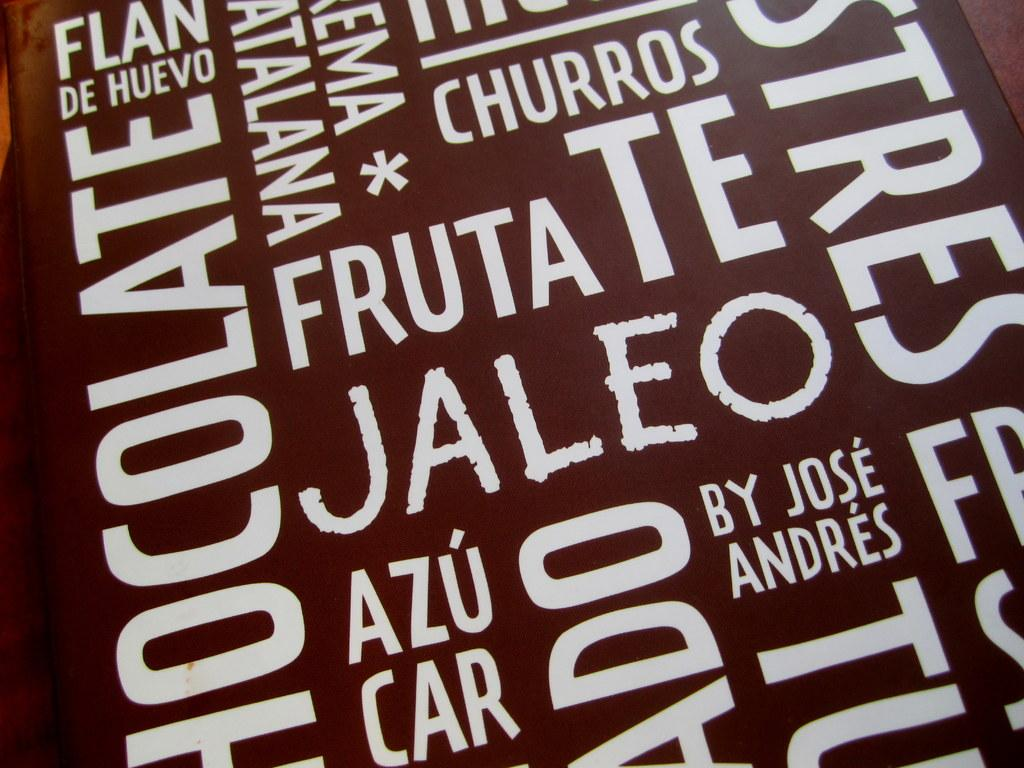Provide a one-sentence caption for the provided image. white letters on a brown background including churros by jose andres. 